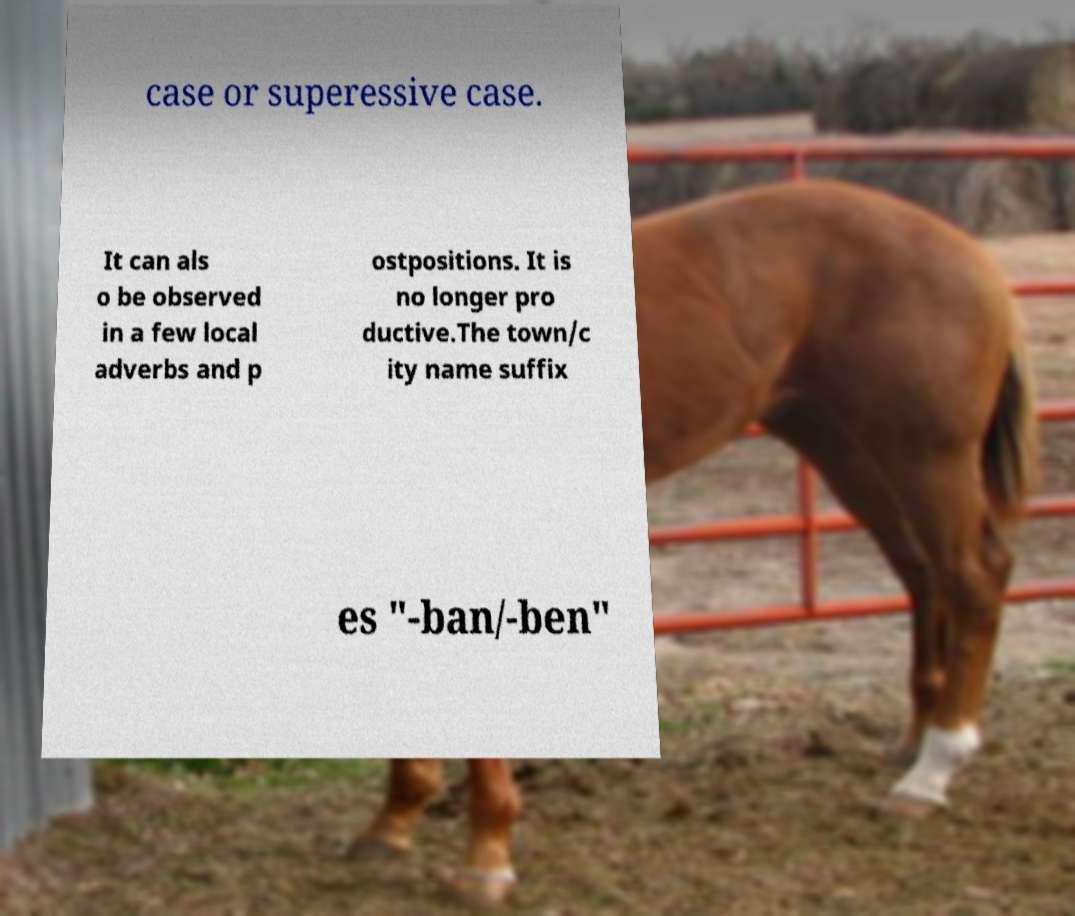There's text embedded in this image that I need extracted. Can you transcribe it verbatim? case or superessive case. It can als o be observed in a few local adverbs and p ostpositions. It is no longer pro ductive.The town/c ity name suffix es "-ban/-ben" 